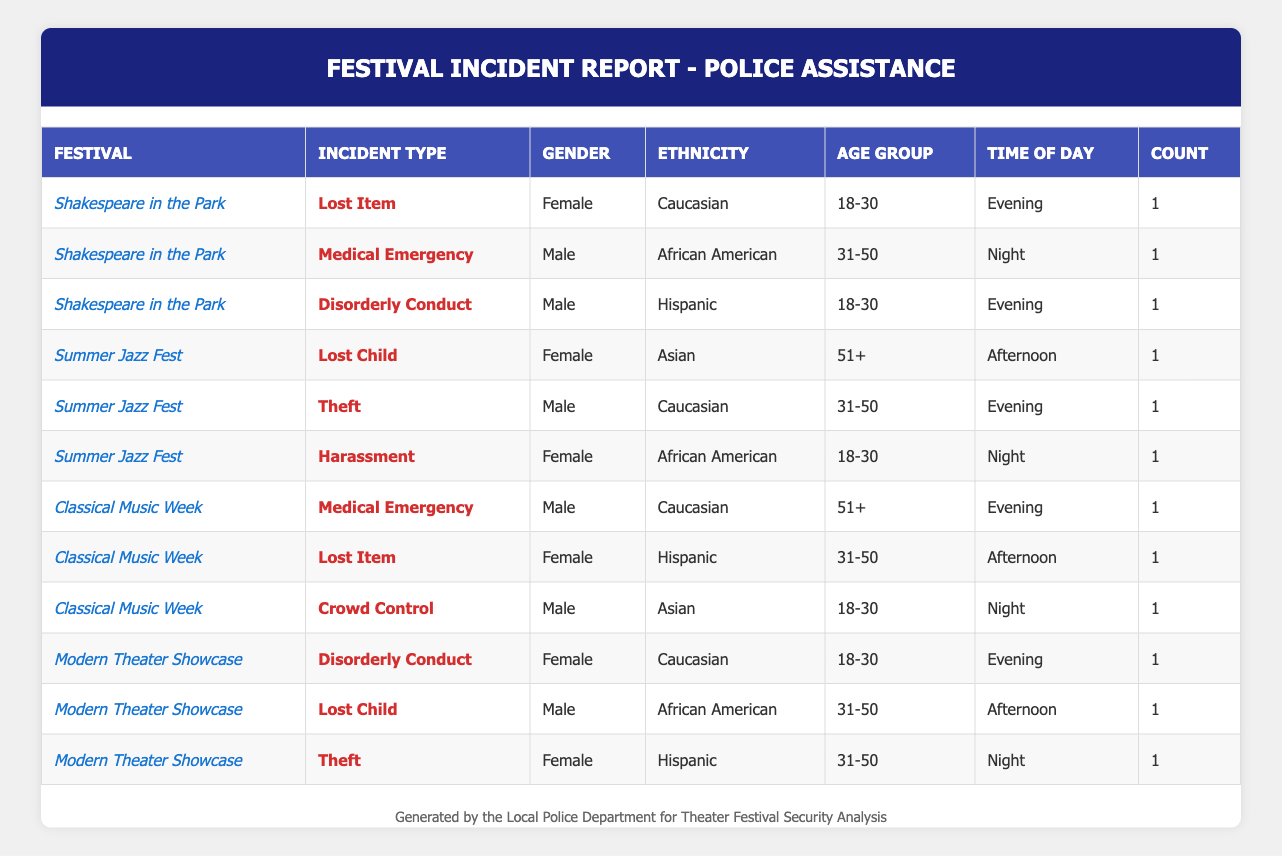What is the total number of incidents reported during the Shakespeare in the Park festival? From the table, we can see three incidents listed under Shakespeare in the Park: Lost Item, Medical Emergency, and Disorderly Conduct. Therefore, the total number of incidents is 3.
Answer: 3 Which gender had the most reported incidents across all festivals? By examining the table, the incidents can be categorized by gender: Males have 5 incidents (1 Medical Emergency, 1 Disorderly Conduct, 1 Theft, 1 Lost Child, 1 Crowd Control), while Females have 5 incidents (1 Lost Item, 1 Harassment, 1 Medical Emergency, 1 Disorderly Conduct, 1 Theft). In this case, both genders have an equal number of incidents reported.
Answer: Equal Is there a reported incident involving an Asian individual during a festival? Looking at the table, there is one incident reported involving an Asian individual, specifically for Crowd Control at the Classical Music Week festival. Therefore, the answer is yes.
Answer: Yes What is the most common incident type reported during the festivals, based on the data? The incident types listed in the table are Lost Item, Medical Emergency, Disorderly Conduct, Lost Child, Theft, and Harassment. Each type appears once except for Lost Item, which appears twice. Therefore, Lost Item is the most common incident type.
Answer: Lost Item How many incidents were reported during the evening across all festivals? In the table, we can find the incidents during the evening: Shakespeare in the Park (Lost Item, Disorderly Conduct), Summer Jazz Fest (Theft), Classical Music Week (Medical Emergency), Modern Theater Showcase (Disorderly Conduct). There are a total of 5 incidents during the evening.
Answer: 5 What percentage of the reported incidents involved females? There are 10 total incidents reported across all festivals. Females are involved in 5 of these incidents (Lost Item, Harassment, Medical Emergency, Disorderly Conduct, Theft). To calculate the percentage: (5/10) * 100 = 50%.
Answer: 50% Did any incidents involve individuals aged over 50? Searching through the table, there are two incidents involving individuals over 50 years old: one Medical Emergency at Classical Music Week and a Lost Child incident at Summer Jazz Fest, both of which have individuals aged 55 and 62 respectively.
Answer: Yes Which festival had the highest number of male incidents? Analyzing the festivals: Shakespeare in the Park has 2 male incidents, Summer Jazz Fest also has 2 male incidents, Classical Music Week has 2 male incidents, and Modern Theater Showcase has 2 male incidents. Since each festival has an equal number of male incidents, none stands out above the rest.
Answer: None How many different incident types occurred at Modern Theater Showcase? In the Modern Theater Showcase, the incident types are Disorderly Conduct, Lost Child, and Theft. This totals to 3 different incident types.
Answer: 3 